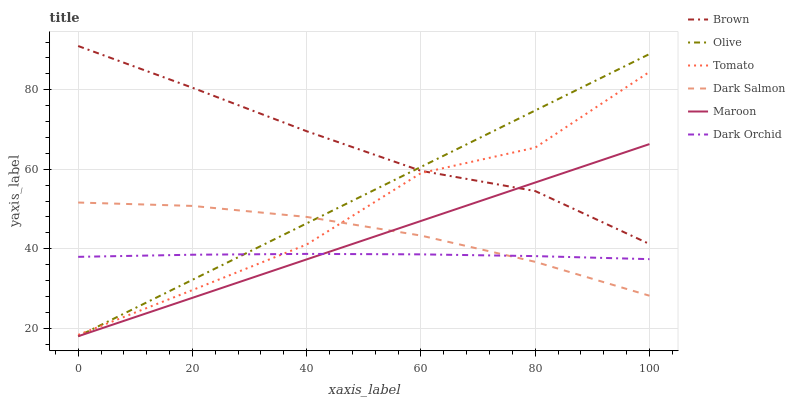Does Dark Orchid have the minimum area under the curve?
Answer yes or no. Yes. Does Brown have the maximum area under the curve?
Answer yes or no. Yes. Does Dark Salmon have the minimum area under the curve?
Answer yes or no. No. Does Dark Salmon have the maximum area under the curve?
Answer yes or no. No. Is Maroon the smoothest?
Answer yes or no. Yes. Is Tomato the roughest?
Answer yes or no. Yes. Is Brown the smoothest?
Answer yes or no. No. Is Brown the roughest?
Answer yes or no. No. Does Maroon have the lowest value?
Answer yes or no. Yes. Does Dark Salmon have the lowest value?
Answer yes or no. No. Does Brown have the highest value?
Answer yes or no. Yes. Does Dark Salmon have the highest value?
Answer yes or no. No. Is Dark Salmon less than Brown?
Answer yes or no. Yes. Is Tomato greater than Maroon?
Answer yes or no. Yes. Does Dark Salmon intersect Maroon?
Answer yes or no. Yes. Is Dark Salmon less than Maroon?
Answer yes or no. No. Is Dark Salmon greater than Maroon?
Answer yes or no. No. Does Dark Salmon intersect Brown?
Answer yes or no. No. 